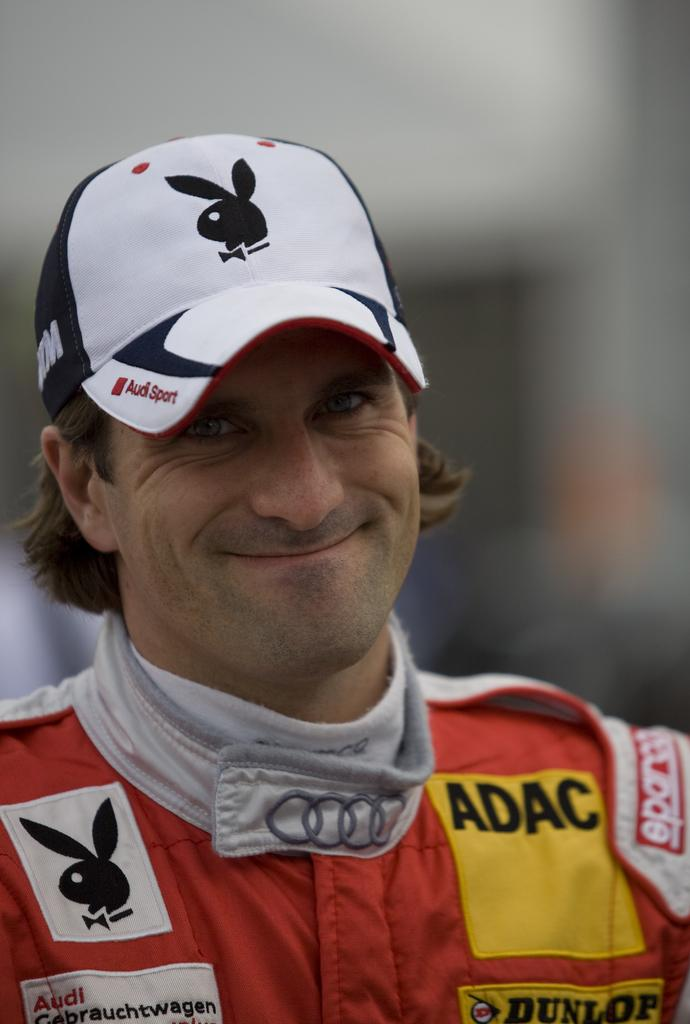What is the main subject of the image? There is a person in the image. What is the person wearing on their upper body? The person is wearing an orange shirt. What type of headwear is the person wearing? The person is wearing a cap. What expression does the person have? The person is smiling. Can you describe the background of the image? The background of the image is blurred. Can you see any snails crawling on the person's cap in the image? There are no snails visible on the person's cap in the image. What type of furniture can be seen in the bedroom in the image? There is no bedroom present in the image. What type of goods can be seen being sold in the market in the image? There is no market present in the image. 